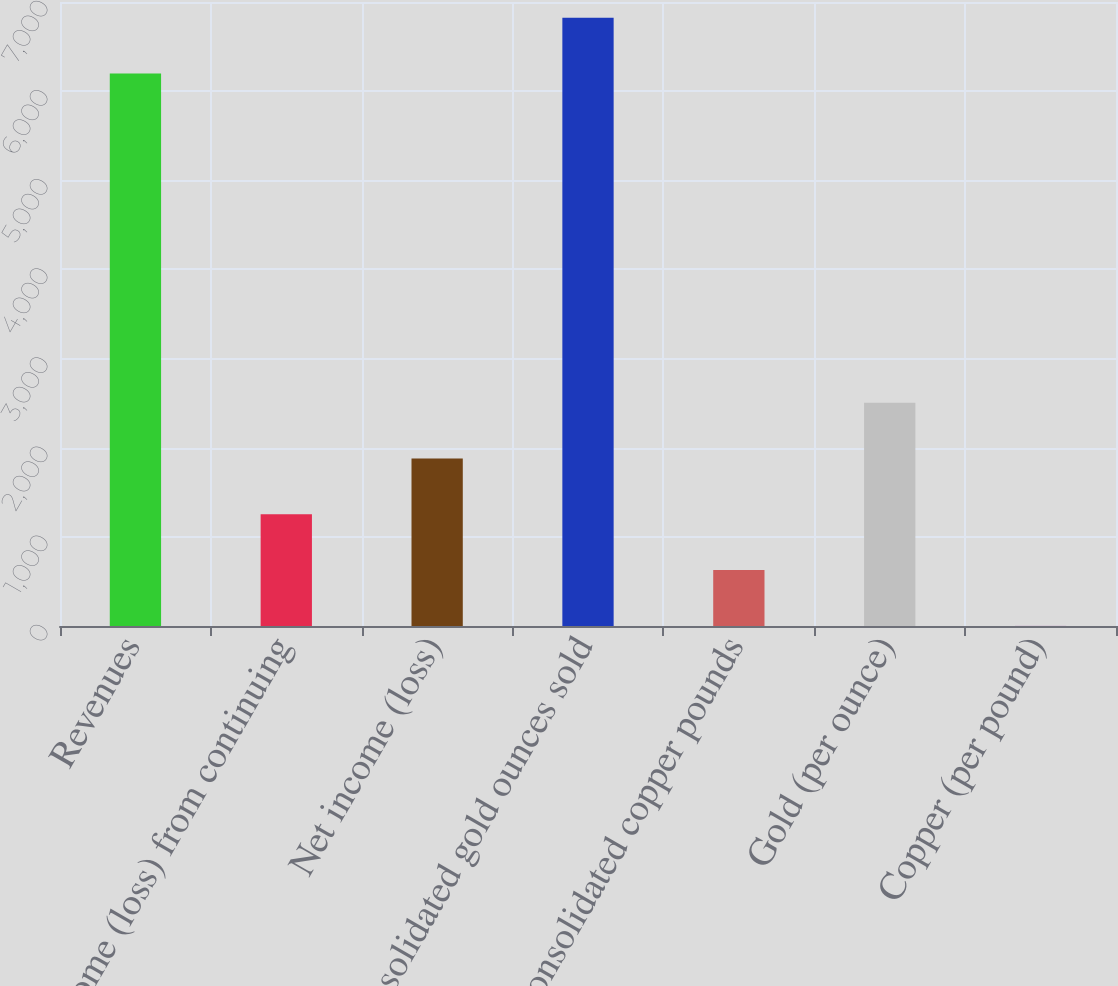<chart> <loc_0><loc_0><loc_500><loc_500><bar_chart><fcel>Revenues<fcel>Income (loss) from continuing<fcel>Net income (loss)<fcel>Consolidated gold ounces sold<fcel>Consolidated copper pounds<fcel>Gold (per ounce)<fcel>Copper (per pound)<nl><fcel>6199<fcel>1253.07<fcel>1878.31<fcel>6824.24<fcel>627.83<fcel>2503.55<fcel>2.59<nl></chart> 